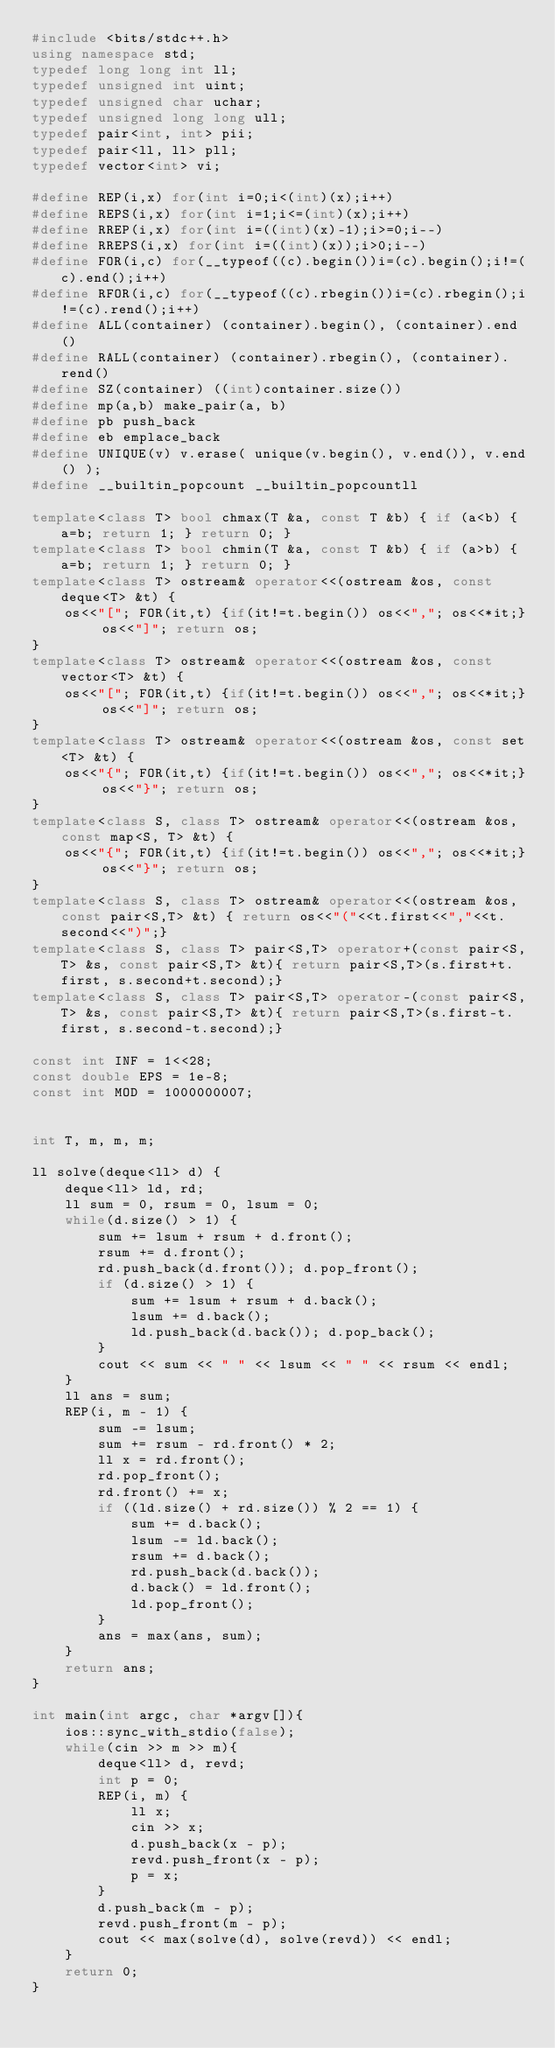<code> <loc_0><loc_0><loc_500><loc_500><_C++_>#include <bits/stdc++.h>
using namespace std;
typedef long long int ll;
typedef unsigned int uint;
typedef unsigned char uchar;
typedef unsigned long long ull;
typedef pair<int, int> pii;
typedef pair<ll, ll> pll;
typedef vector<int> vi;

#define REP(i,x) for(int i=0;i<(int)(x);i++)
#define REPS(i,x) for(int i=1;i<=(int)(x);i++)
#define RREP(i,x) for(int i=((int)(x)-1);i>=0;i--)
#define RREPS(i,x) for(int i=((int)(x));i>0;i--)
#define FOR(i,c) for(__typeof((c).begin())i=(c).begin();i!=(c).end();i++)
#define RFOR(i,c) for(__typeof((c).rbegin())i=(c).rbegin();i!=(c).rend();i++)
#define ALL(container) (container).begin(), (container).end()
#define RALL(container) (container).rbegin(), (container).rend()
#define SZ(container) ((int)container.size())
#define mp(a,b) make_pair(a, b)
#define pb push_back
#define eb emplace_back
#define UNIQUE(v) v.erase( unique(v.begin(), v.end()), v.end() );
#define __builtin_popcount __builtin_popcountll

template<class T> bool chmax(T &a, const T &b) { if (a<b) { a=b; return 1; } return 0; }
template<class T> bool chmin(T &a, const T &b) { if (a>b) { a=b; return 1; } return 0; }
template<class T> ostream& operator<<(ostream &os, const deque<T> &t) {
    os<<"["; FOR(it,t) {if(it!=t.begin()) os<<","; os<<*it;} os<<"]"; return os;
}
template<class T> ostream& operator<<(ostream &os, const vector<T> &t) {
    os<<"["; FOR(it,t) {if(it!=t.begin()) os<<","; os<<*it;} os<<"]"; return os;
}
template<class T> ostream& operator<<(ostream &os, const set<T> &t) {
    os<<"{"; FOR(it,t) {if(it!=t.begin()) os<<","; os<<*it;} os<<"}"; return os;
}
template<class S, class T> ostream& operator<<(ostream &os, const map<S, T> &t) {
    os<<"{"; FOR(it,t) {if(it!=t.begin()) os<<","; os<<*it;} os<<"}"; return os;
}
template<class S, class T> ostream& operator<<(ostream &os, const pair<S,T> &t) { return os<<"("<<t.first<<","<<t.second<<")";}
template<class S, class T> pair<S,T> operator+(const pair<S,T> &s, const pair<S,T> &t){ return pair<S,T>(s.first+t.first, s.second+t.second);}
template<class S, class T> pair<S,T> operator-(const pair<S,T> &s, const pair<S,T> &t){ return pair<S,T>(s.first-t.first, s.second-t.second);}

const int INF = 1<<28;
const double EPS = 1e-8;
const int MOD = 1000000007;


int T, m, m, m;

ll solve(deque<ll> d) {
    deque<ll> ld, rd;
    ll sum = 0, rsum = 0, lsum = 0;
    while(d.size() > 1) {
        sum += lsum + rsum + d.front();
        rsum += d.front();
        rd.push_back(d.front()); d.pop_front();
        if (d.size() > 1) {
            sum += lsum + rsum + d.back();
            lsum += d.back();
            ld.push_back(d.back()); d.pop_back();
        }
        cout << sum << " " << lsum << " " << rsum << endl;
    }
    ll ans = sum;
    REP(i, m - 1) {
        sum -= lsum;
        sum += rsum - rd.front() * 2;
        ll x = rd.front();
        rd.pop_front();
        rd.front() += x;
        if ((ld.size() + rd.size()) % 2 == 1) {
            sum += d.back();
            lsum -= ld.back();
            rsum += d.back();
            rd.push_back(d.back());
            d.back() = ld.front();
            ld.pop_front();
        }
        ans = max(ans, sum);
    }
    return ans;
}

int main(int argc, char *argv[]){
    ios::sync_with_stdio(false);
    while(cin >> m >> m){
        deque<ll> d, revd;
        int p = 0;
        REP(i, m) {
            ll x;
            cin >> x;
            d.push_back(x - p);
            revd.push_front(x - p);
            p = x;
        }
        d.push_back(m - p);
        revd.push_front(m - p);
        cout << max(solve(d), solve(revd)) << endl;
    }
    return 0;
}
</code> 